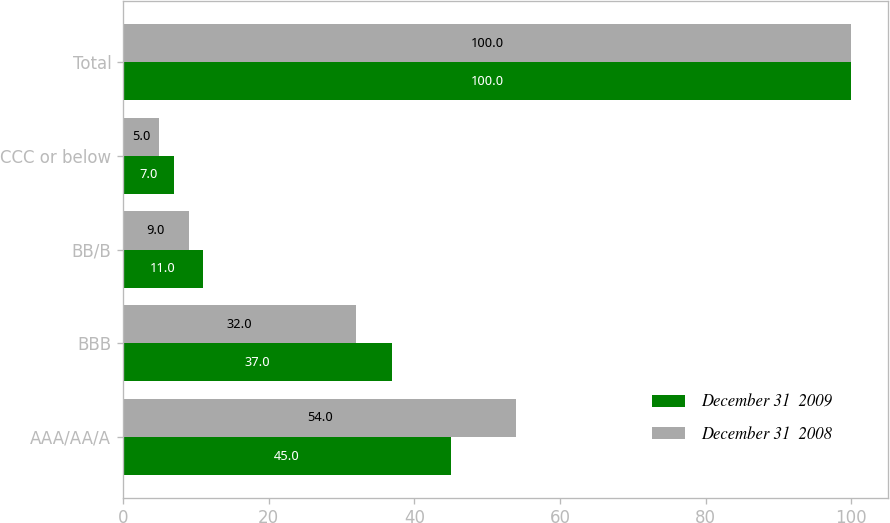<chart> <loc_0><loc_0><loc_500><loc_500><stacked_bar_chart><ecel><fcel>AAA/AA/A<fcel>BBB<fcel>BB/B<fcel>CCC or below<fcel>Total<nl><fcel>December 31  2009<fcel>45<fcel>37<fcel>11<fcel>7<fcel>100<nl><fcel>December 31  2008<fcel>54<fcel>32<fcel>9<fcel>5<fcel>100<nl></chart> 